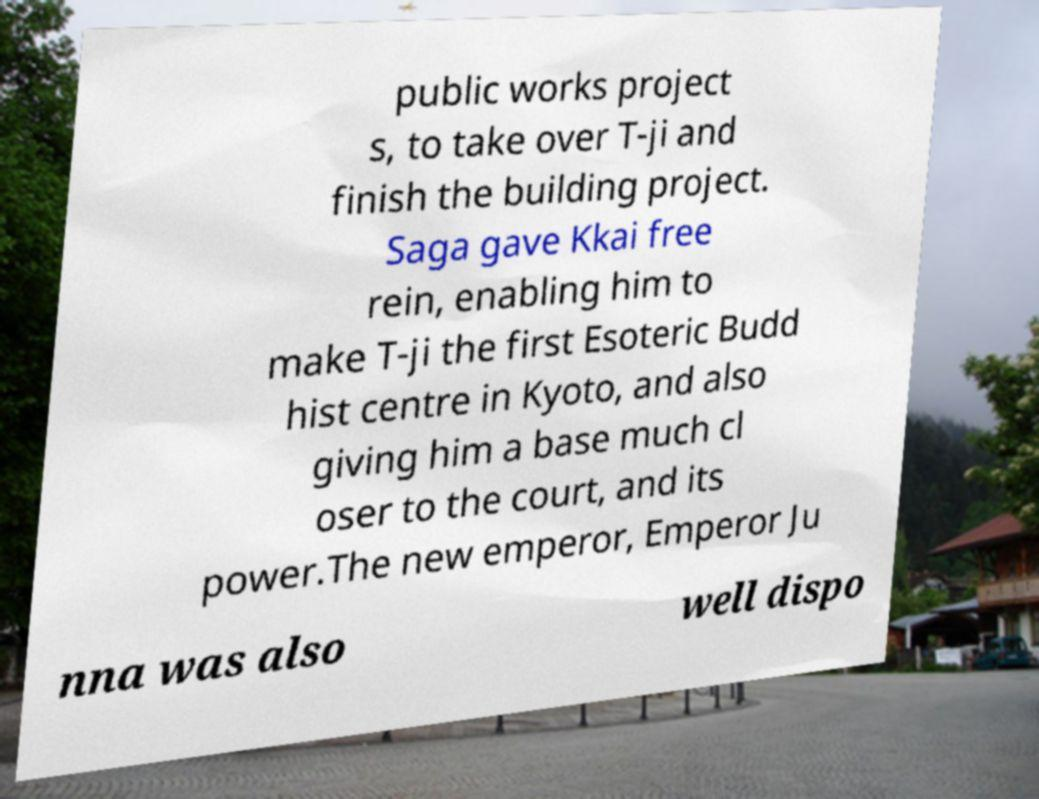Could you assist in decoding the text presented in this image and type it out clearly? public works project s, to take over T-ji and finish the building project. Saga gave Kkai free rein, enabling him to make T-ji the first Esoteric Budd hist centre in Kyoto, and also giving him a base much cl oser to the court, and its power.The new emperor, Emperor Ju nna was also well dispo 